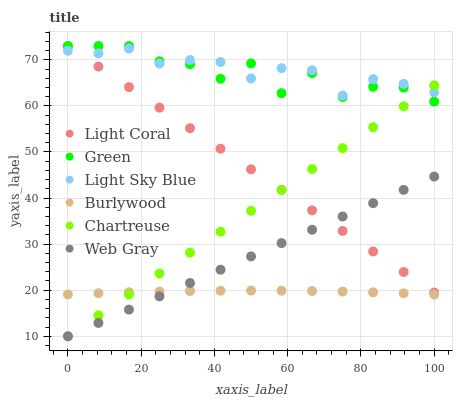Does Burlywood have the minimum area under the curve?
Answer yes or no. Yes. Does Light Sky Blue have the maximum area under the curve?
Answer yes or no. Yes. Does Light Coral have the minimum area under the curve?
Answer yes or no. No. Does Light Coral have the maximum area under the curve?
Answer yes or no. No. Is Chartreuse the smoothest?
Answer yes or no. Yes. Is Green the roughest?
Answer yes or no. Yes. Is Burlywood the smoothest?
Answer yes or no. No. Is Burlywood the roughest?
Answer yes or no. No. Does Web Gray have the lowest value?
Answer yes or no. Yes. Does Burlywood have the lowest value?
Answer yes or no. No. Does Green have the highest value?
Answer yes or no. Yes. Does Burlywood have the highest value?
Answer yes or no. No. Is Burlywood less than Green?
Answer yes or no. Yes. Is Green greater than Burlywood?
Answer yes or no. Yes. Does Web Gray intersect Burlywood?
Answer yes or no. Yes. Is Web Gray less than Burlywood?
Answer yes or no. No. Is Web Gray greater than Burlywood?
Answer yes or no. No. Does Burlywood intersect Green?
Answer yes or no. No. 